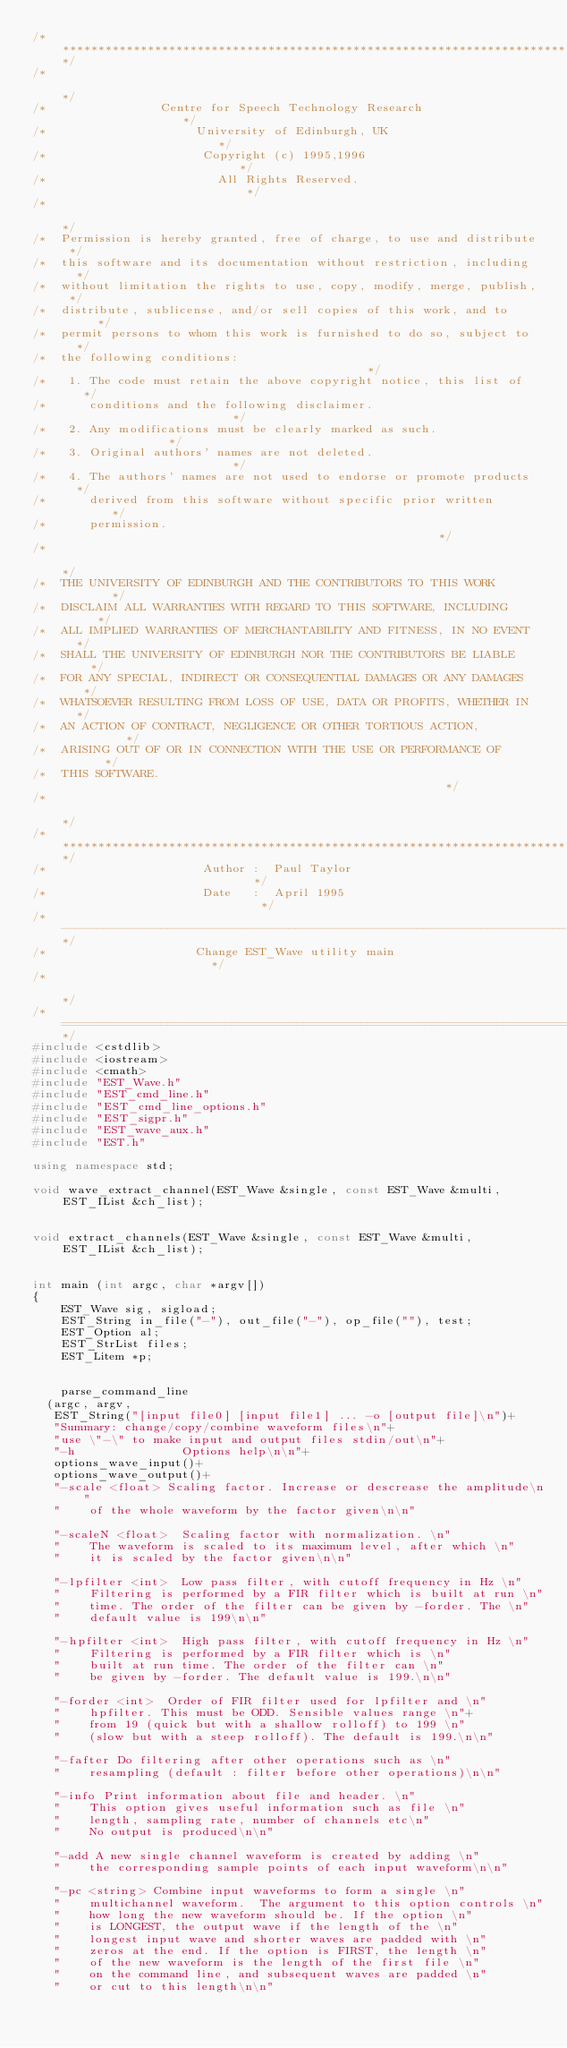<code> <loc_0><loc_0><loc_500><loc_500><_C++_>/*************************************************************************/
/*                                                                       */
/*                Centre for Speech Technology Research                  */
/*                     University of Edinburgh, UK                       */
/*                      Copyright (c) 1995,1996                          */
/*                        All Rights Reserved.                           */
/*                                                                       */
/*  Permission is hereby granted, free of charge, to use and distribute  */
/*  this software and its documentation without restriction, including   */
/*  without limitation the rights to use, copy, modify, merge, publish,  */
/*  distribute, sublicense, and/or sell copies of this work, and to      */
/*  permit persons to whom this work is furnished to do so, subject to   */
/*  the following conditions:                                            */
/*   1. The code must retain the above copyright notice, this list of    */
/*      conditions and the following disclaimer.                         */
/*   2. Any modifications must be clearly marked as such.                */
/*   3. Original authors' names are not deleted.                         */
/*   4. The authors' names are not used to endorse or promote products   */
/*      derived from this software without specific prior written        */
/*      permission.                                                      */
/*                                                                       */
/*  THE UNIVERSITY OF EDINBURGH AND THE CONTRIBUTORS TO THIS WORK        */
/*  DISCLAIM ALL WARRANTIES WITH REGARD TO THIS SOFTWARE, INCLUDING      */
/*  ALL IMPLIED WARRANTIES OF MERCHANTABILITY AND FITNESS, IN NO EVENT   */
/*  SHALL THE UNIVERSITY OF EDINBURGH NOR THE CONTRIBUTORS BE LIABLE     */
/*  FOR ANY SPECIAL, INDIRECT OR CONSEQUENTIAL DAMAGES OR ANY DAMAGES    */
/*  WHATSOEVER RESULTING FROM LOSS OF USE, DATA OR PROFITS, WHETHER IN   */
/*  AN ACTION OF CONTRACT, NEGLIGENCE OR OTHER TORTIOUS ACTION,          */
/*  ARISING OUT OF OR IN CONNECTION WITH THE USE OR PERFORMANCE OF       */
/*  THIS SOFTWARE.                                                       */
/*                                                                       */
/*************************************************************************/
/*                      Author :  Paul Taylor                            */
/*                      Date   :  April 1995                             */
/*-----------------------------------------------------------------------*/
/*                     Change EST_Wave utility main                      */
/*                                                                       */
/*=======================================================================*/
#include <cstdlib>
#include <iostream>
#include <cmath>
#include "EST_Wave.h"
#include "EST_cmd_line.h"
#include "EST_cmd_line_options.h"
#include "EST_sigpr.h"
#include "EST_wave_aux.h"
#include "EST.h"

using namespace std;

void wave_extract_channel(EST_Wave &single, const EST_Wave &multi,  EST_IList &ch_list);


void extract_channels(EST_Wave &single, const EST_Wave &multi,  EST_IList &ch_list);


int main (int argc, char *argv[])
{
    EST_Wave sig, sigload;
    EST_String in_file("-"), out_file("-"), op_file(""), test;
    EST_Option al;
    EST_StrList files;
    EST_Litem *p;


    parse_command_line
	(argc, argv, 
	 EST_String("[input file0] [input file1] ... -o [output file]\n")+
	 "Summary: change/copy/combine waveform files\n"+
	 "use \"-\" to make input and output files stdin/out\n"+
	 "-h               Options help\n\n"+
	 options_wave_input()+ 
	 options_wave_output()+
	 "-scale <float> Scaling factor. Increase or descrease the amplitude\n"
	 "    of the whole waveform by the factor given\n\n"

	 "-scaleN <float>  Scaling factor with normalization. \n"
	 "    The waveform is scaled to its maximum level, after which \n"
	 "    it is scaled by the factor given\n\n"

	 "-lpfilter <int>  Low pass filter, with cutoff frequency in Hz \n"
	 "    Filtering is performed by a FIR filter which is built at run \n"
	 "    time. The order of the filter can be given by -forder. The \n"
	 "    default value is 199\n\n"

	 "-hpfilter <int>  High pass filter, with cutoff frequency in Hz \n"
	 "    Filtering is performed by a FIR filter which is \n"
	 "    built at run time. The order of the filter can \n"
	 "    be given by -forder. The default value is 199.\n\n"

	 "-forder <int>  Order of FIR filter used for lpfilter and \n"
	 "    hpfilter. This must be ODD. Sensible values range \n"+
	 "    from 19 (quick but with a shallow rolloff) to 199 \n"
	 "    (slow but with a steep rolloff). The default is 199.\n\n"

	 "-fafter Do filtering after other operations such as \n"
	 "    resampling (default : filter before other operations)\n\n"

	 "-info Print information about file and header. \n"
	 "    This option gives useful information such as file \n"
	 "    length, sampling rate, number of channels etc\n"
	 "    No output is produced\n\n"

	 "-add A new single channel waveform is created by adding \n"
	 "    the corresponding sample points of each input waveform\n\n"

	 "-pc <string> Combine input waveforms to form a single \n"
	 "    multichannel waveform.  The argument to this option controls \n"
	 "    how long the new waveform should be. If the option \n"
	 "    is LONGEST, the output wave if the length of the \n"
	 "    longest input wave and shorter waves are padded with \n"
	 "    zeros at the end. If the option is FIRST, the length \n"
	 "    of the new waveform is the length of the first file \n"
	 "    on the command line, and subsequent waves are padded \n"
	 "    or cut to this length\n\n"
</code> 